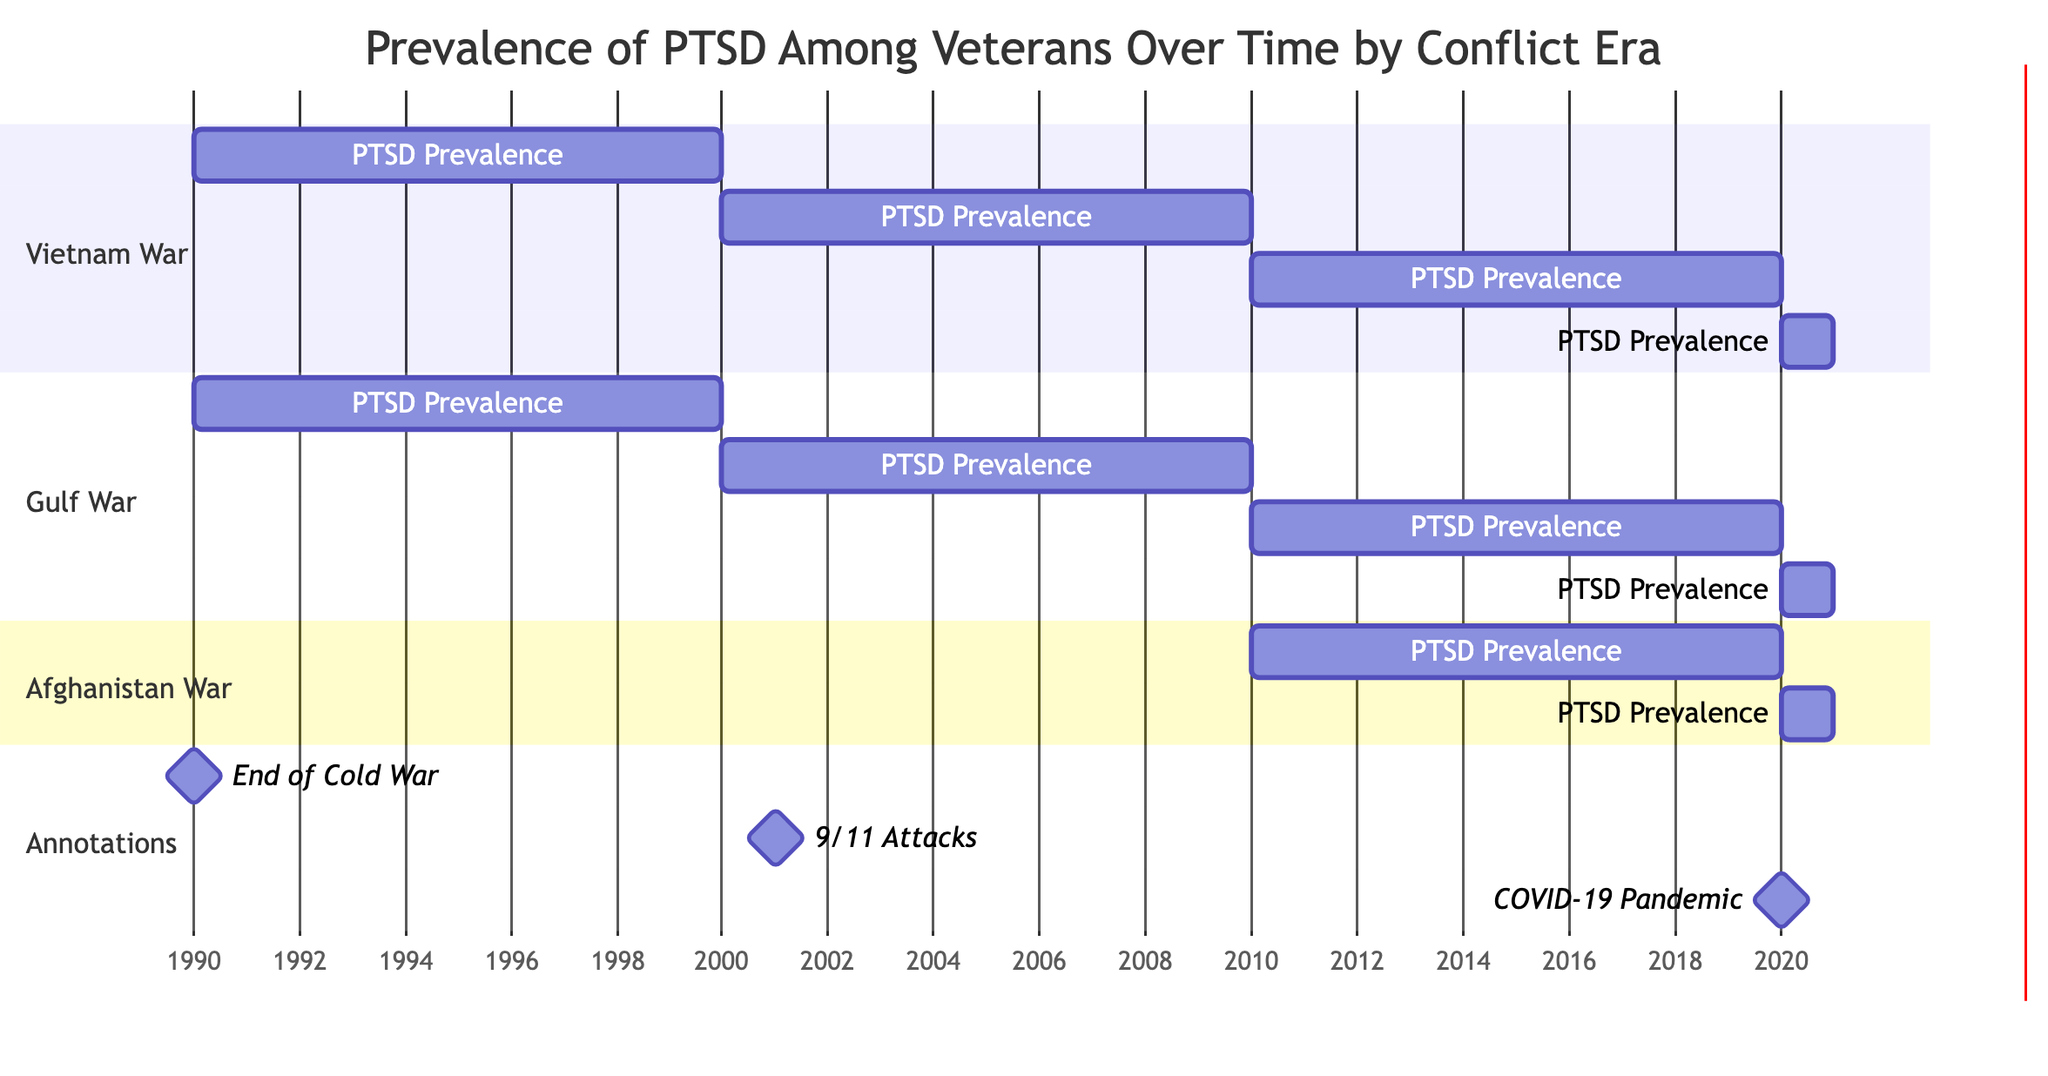What was the PTSD prevalence for Vietnam War veterans in 1990? The diagram indicates that the PTSD prevalence for Vietnam War veterans was 15.2% in 1990 as shown in the section for Vietnam War.
Answer: 15.2% What is the lowest PTSD prevalence recorded for Gulf War veterans in the given years? By examining the Gulf War section, the lowest PTSD prevalence recorded is 10.7%, which occurred in 2021.
Answer: 10.7% Which conflict era had the highest PTSD prevalence in 2010? In 2010, the Afghanistan War veterans had the highest PTSD prevalence at 20.3%, whereas the other conflict eras had lower values.
Answer: Afghanistan War What was the PTSD prevalence trend for Vietnam War veterans from 1990 to 2020? The trend shows a decrease in PTSD prevalence from 15.2% in 1990, dropping to 11.0% in 2020, indicating a declining trend over the years for this group.
Answer: Decreasing What significant event was marked by a milestone in 2001? The diagram marks the 9/11 Attacks as a significant event in 2001, indicated by the milestone annotation at that year.
Answer: 9/11 Attacks What is the PTSD prevalence change for Afghanistan War veterans from 2020 to 2021? In 2020, the PTSD prevalence for Afghanistan War veterans was 17.2%, and in 2021, it decreased to 17.2%, showing no change during that period.
Answer: No change Which conflict era experienced a consistent decrease in PTSD prevalence from 2010 to 2021? The Gulf War section shows a consistent decrease in PTSD prevalence from 11.8% in 2010 to 10.7% in 2021, making this era an example of a consistent decline.
Answer: Gulf War How many conflict eras are represented in the diagram? The diagram shows three conflict eras represented: Vietnam War, Gulf War, and Afghanistan War, totaling three eras.
Answer: Three What was the PTSD prevalence among Vietnam War veterans in 2010? For Vietnam War veterans in 2010, the PTSD prevalence was recorded at 12.3% as indicated in the relevant section of the diagram.
Answer: 12.3% 